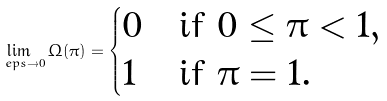Convert formula to latex. <formula><loc_0><loc_0><loc_500><loc_500>\lim _ { \ e p s \to 0 } \Omega ( \pi ) = \begin{cases} 0 & \text {if } 0 \leq \pi < 1 , \\ 1 & \text {if } \pi = 1 . \end{cases}</formula> 